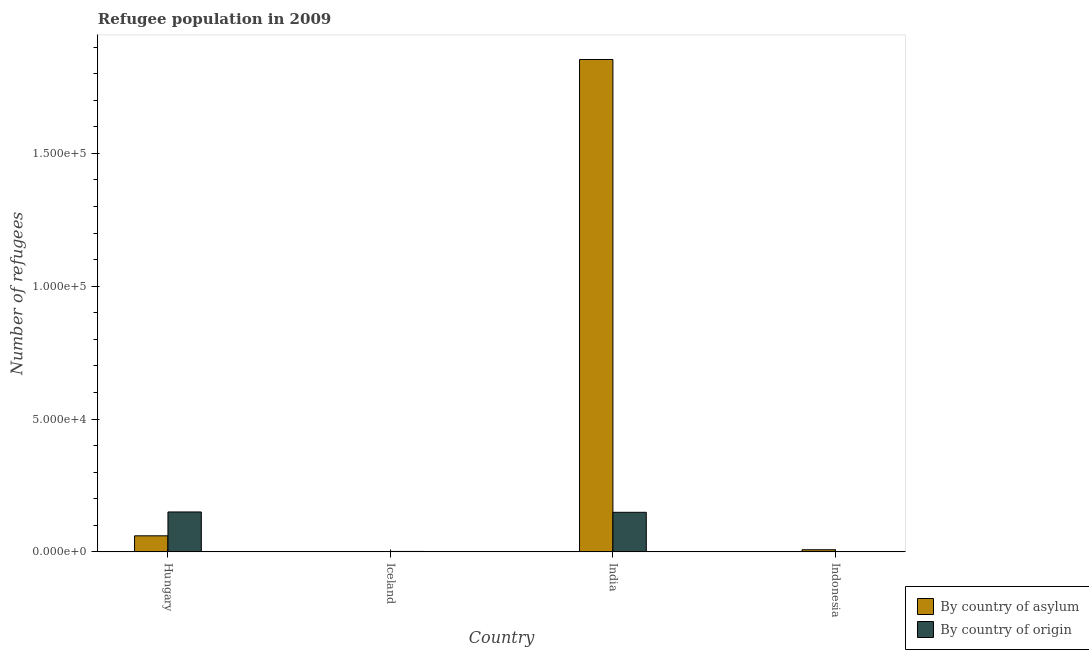How many different coloured bars are there?
Keep it short and to the point. 2. How many bars are there on the 4th tick from the right?
Provide a short and direct response. 2. What is the label of the 4th group of bars from the left?
Ensure brevity in your answer.  Indonesia. What is the number of refugees by country of origin in Hungary?
Provide a succinct answer. 1.50e+04. Across all countries, what is the maximum number of refugees by country of asylum?
Make the answer very short. 1.85e+05. Across all countries, what is the minimum number of refugees by country of origin?
Provide a succinct answer. 62. What is the total number of refugees by country of origin in the graph?
Ensure brevity in your answer.  3.01e+04. What is the difference between the number of refugees by country of asylum in Iceland and that in Indonesia?
Offer a very short reply. -736. What is the difference between the number of refugees by country of origin in Indonesia and the number of refugees by country of asylum in Iceland?
Provide a succinct answer. 0. What is the average number of refugees by country of asylum per country?
Give a very brief answer. 4.81e+04. What is the difference between the number of refugees by country of asylum and number of refugees by country of origin in Hungary?
Your response must be concise. -8976. What is the ratio of the number of refugees by country of origin in Iceland to that in India?
Give a very brief answer. 0.01. What is the difference between the highest and the second highest number of refugees by country of asylum?
Your answer should be very brief. 1.79e+05. What is the difference between the highest and the lowest number of refugees by country of asylum?
Keep it short and to the point. 1.85e+05. What does the 2nd bar from the left in India represents?
Provide a short and direct response. By country of origin. What does the 2nd bar from the right in India represents?
Your answer should be very brief. By country of asylum. Are all the bars in the graph horizontal?
Offer a very short reply. No. How many countries are there in the graph?
Make the answer very short. 4. Are the values on the major ticks of Y-axis written in scientific E-notation?
Make the answer very short. Yes. Does the graph contain grids?
Provide a succinct answer. No. How many legend labels are there?
Make the answer very short. 2. How are the legend labels stacked?
Ensure brevity in your answer.  Vertical. What is the title of the graph?
Make the answer very short. Refugee population in 2009. What is the label or title of the X-axis?
Offer a very short reply. Country. What is the label or title of the Y-axis?
Offer a very short reply. Number of refugees. What is the Number of refugees in By country of asylum in Hungary?
Give a very brief answer. 6044. What is the Number of refugees in By country of origin in Hungary?
Your answer should be compact. 1.50e+04. What is the Number of refugees in By country of origin in Iceland?
Your answer should be very brief. 170. What is the Number of refugees in By country of asylum in India?
Your answer should be very brief. 1.85e+05. What is the Number of refugees in By country of origin in India?
Your answer should be compact. 1.49e+04. What is the Number of refugees of By country of asylum in Indonesia?
Offer a terse response. 798. What is the Number of refugees of By country of origin in Indonesia?
Ensure brevity in your answer.  62. Across all countries, what is the maximum Number of refugees of By country of asylum?
Your response must be concise. 1.85e+05. Across all countries, what is the maximum Number of refugees of By country of origin?
Offer a terse response. 1.50e+04. Across all countries, what is the minimum Number of refugees in By country of asylum?
Your answer should be very brief. 62. What is the total Number of refugees of By country of asylum in the graph?
Make the answer very short. 1.92e+05. What is the total Number of refugees of By country of origin in the graph?
Keep it short and to the point. 3.01e+04. What is the difference between the Number of refugees in By country of asylum in Hungary and that in Iceland?
Ensure brevity in your answer.  5982. What is the difference between the Number of refugees in By country of origin in Hungary and that in Iceland?
Your response must be concise. 1.48e+04. What is the difference between the Number of refugees in By country of asylum in Hungary and that in India?
Ensure brevity in your answer.  -1.79e+05. What is the difference between the Number of refugees in By country of origin in Hungary and that in India?
Offer a very short reply. 127. What is the difference between the Number of refugees of By country of asylum in Hungary and that in Indonesia?
Your answer should be compact. 5246. What is the difference between the Number of refugees in By country of origin in Hungary and that in Indonesia?
Keep it short and to the point. 1.50e+04. What is the difference between the Number of refugees of By country of asylum in Iceland and that in India?
Offer a very short reply. -1.85e+05. What is the difference between the Number of refugees in By country of origin in Iceland and that in India?
Keep it short and to the point. -1.47e+04. What is the difference between the Number of refugees of By country of asylum in Iceland and that in Indonesia?
Provide a short and direct response. -736. What is the difference between the Number of refugees in By country of origin in Iceland and that in Indonesia?
Make the answer very short. 108. What is the difference between the Number of refugees of By country of asylum in India and that in Indonesia?
Provide a succinct answer. 1.85e+05. What is the difference between the Number of refugees of By country of origin in India and that in Indonesia?
Give a very brief answer. 1.48e+04. What is the difference between the Number of refugees of By country of asylum in Hungary and the Number of refugees of By country of origin in Iceland?
Provide a succinct answer. 5874. What is the difference between the Number of refugees of By country of asylum in Hungary and the Number of refugees of By country of origin in India?
Your response must be concise. -8849. What is the difference between the Number of refugees of By country of asylum in Hungary and the Number of refugees of By country of origin in Indonesia?
Provide a short and direct response. 5982. What is the difference between the Number of refugees in By country of asylum in Iceland and the Number of refugees in By country of origin in India?
Your response must be concise. -1.48e+04. What is the difference between the Number of refugees in By country of asylum in India and the Number of refugees in By country of origin in Indonesia?
Your response must be concise. 1.85e+05. What is the average Number of refugees in By country of asylum per country?
Provide a short and direct response. 4.81e+04. What is the average Number of refugees in By country of origin per country?
Provide a short and direct response. 7536.25. What is the difference between the Number of refugees of By country of asylum and Number of refugees of By country of origin in Hungary?
Keep it short and to the point. -8976. What is the difference between the Number of refugees in By country of asylum and Number of refugees in By country of origin in Iceland?
Offer a very short reply. -108. What is the difference between the Number of refugees in By country of asylum and Number of refugees in By country of origin in India?
Offer a terse response. 1.70e+05. What is the difference between the Number of refugees of By country of asylum and Number of refugees of By country of origin in Indonesia?
Your answer should be compact. 736. What is the ratio of the Number of refugees in By country of asylum in Hungary to that in Iceland?
Make the answer very short. 97.48. What is the ratio of the Number of refugees in By country of origin in Hungary to that in Iceland?
Give a very brief answer. 88.35. What is the ratio of the Number of refugees of By country of asylum in Hungary to that in India?
Ensure brevity in your answer.  0.03. What is the ratio of the Number of refugees in By country of origin in Hungary to that in India?
Provide a short and direct response. 1.01. What is the ratio of the Number of refugees of By country of asylum in Hungary to that in Indonesia?
Make the answer very short. 7.57. What is the ratio of the Number of refugees of By country of origin in Hungary to that in Indonesia?
Offer a very short reply. 242.26. What is the ratio of the Number of refugees in By country of origin in Iceland to that in India?
Offer a very short reply. 0.01. What is the ratio of the Number of refugees of By country of asylum in Iceland to that in Indonesia?
Your answer should be very brief. 0.08. What is the ratio of the Number of refugees of By country of origin in Iceland to that in Indonesia?
Your answer should be very brief. 2.74. What is the ratio of the Number of refugees of By country of asylum in India to that in Indonesia?
Provide a short and direct response. 232.23. What is the ratio of the Number of refugees of By country of origin in India to that in Indonesia?
Your response must be concise. 240.21. What is the difference between the highest and the second highest Number of refugees of By country of asylum?
Keep it short and to the point. 1.79e+05. What is the difference between the highest and the second highest Number of refugees in By country of origin?
Your response must be concise. 127. What is the difference between the highest and the lowest Number of refugees of By country of asylum?
Your response must be concise. 1.85e+05. What is the difference between the highest and the lowest Number of refugees in By country of origin?
Give a very brief answer. 1.50e+04. 